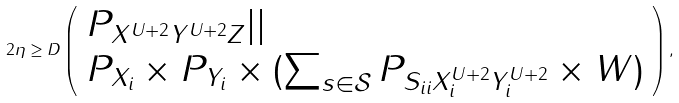<formula> <loc_0><loc_0><loc_500><loc_500>2 \eta \geq D \left ( \begin{array} { l l } P _ { X ^ { U + 2 } Y ^ { U + 2 } Z } | | \\ P _ { X _ { i } } \times P _ { Y _ { i } } \times ( \sum _ { s \in \mathcal { S } } P _ { S _ { i i } X ^ { U + 2 } _ { i } Y ^ { U + 2 } _ { i } } \times W ) \end{array} \right ) ,</formula> 